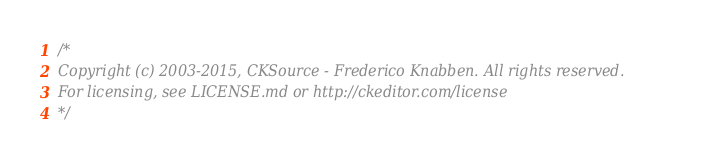Convert code to text. <code><loc_0><loc_0><loc_500><loc_500><_CSS_>/*
Copyright (c) 2003-2015, CKSource - Frederico Knabben. All rights reserved.
For licensing, see LICENSE.md or http://ckeditor.com/license
*/</code> 